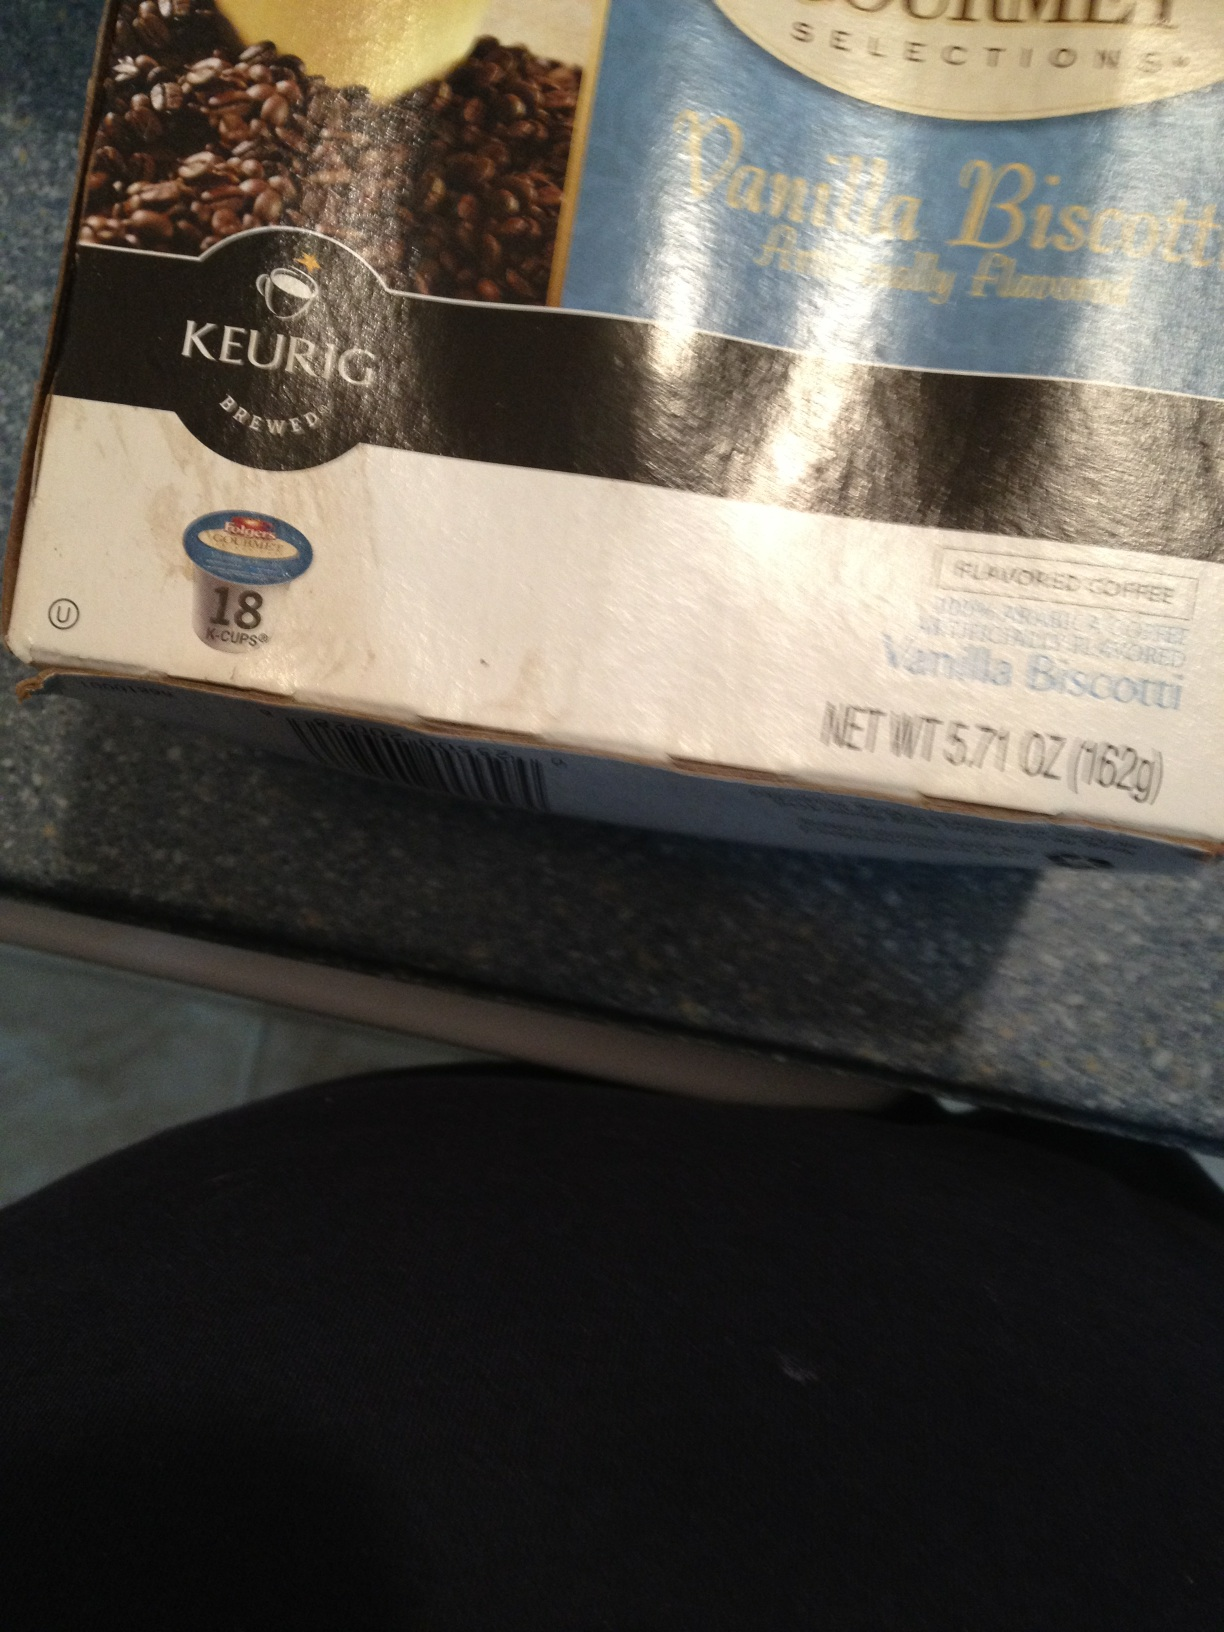Imagine this coffee on an adventure. What would its journey look like? In an enchanted forest where flavors come alive, Vanilla Biscotti embarks on a quest to retrieve the legendary Golden Bean. Armed with its sweet and rich aroma, this heroic coffee traverses through fields of vanilla flowers and bridges made of biscotti crumbs. Along the way, it befriends a group of cheerful coffee beans, and together they battle the Bitter Brew Goblins, restoring balance to the world of flavors. In the end, Vanilla Biscotti returns victorious, its essence now imbued with the golden warmth of the legendary bean, ready to delight the taste buds of all who brew it. 